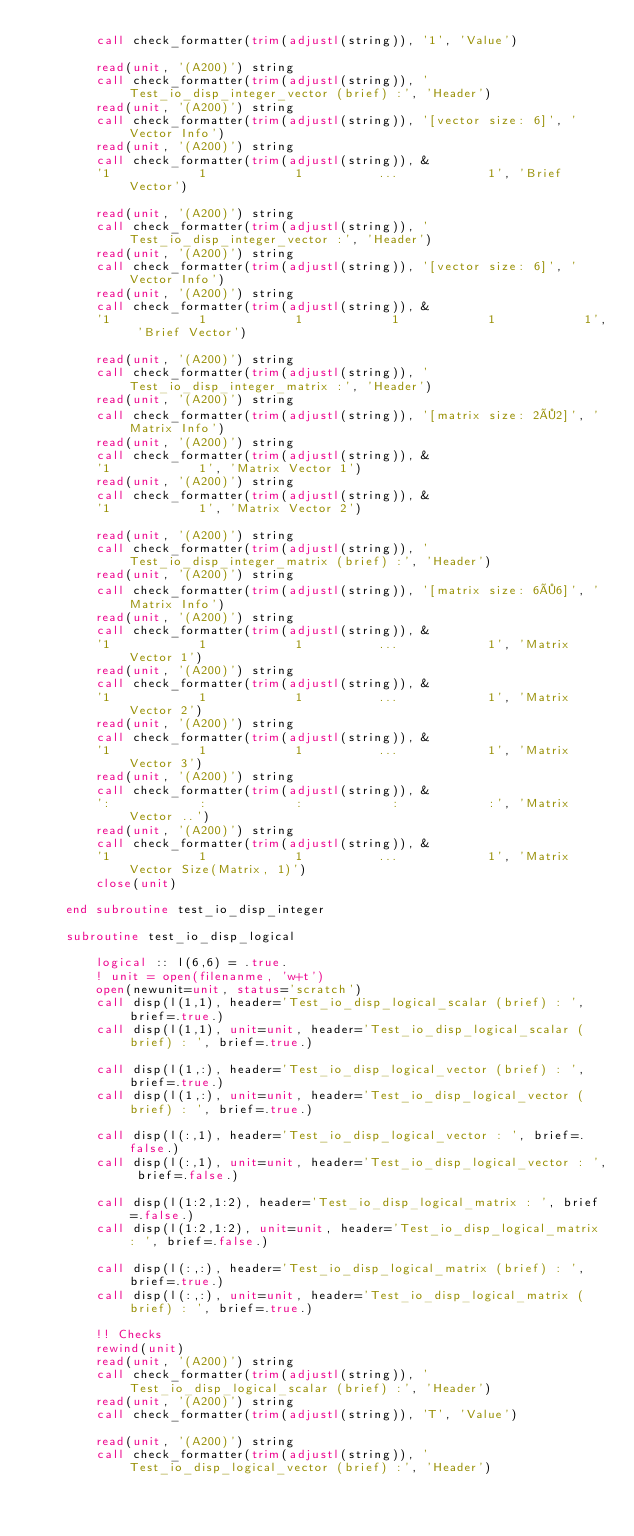<code> <loc_0><loc_0><loc_500><loc_500><_FORTRAN_>        call check_formatter(trim(adjustl(string)), '1', 'Value')

        read(unit, '(A200)') string
        call check_formatter(trim(adjustl(string)), 'Test_io_disp_integer_vector (brief) :', 'Header')
        read(unit, '(A200)') string
        call check_formatter(trim(adjustl(string)), '[vector size: 6]', 'Vector Info')
        read(unit, '(A200)') string
        call check_formatter(trim(adjustl(string)), &
        '1            1            1          ...            1', 'Brief Vector')

        read(unit, '(A200)') string
        call check_formatter(trim(adjustl(string)), 'Test_io_disp_integer_vector :', 'Header')
        read(unit, '(A200)') string
        call check_formatter(trim(adjustl(string)), '[vector size: 6]', 'Vector Info')
        read(unit, '(A200)') string
        call check_formatter(trim(adjustl(string)), &
        '1            1            1            1            1            1', 'Brief Vector')

        read(unit, '(A200)') string
        call check_formatter(trim(adjustl(string)), 'Test_io_disp_integer_matrix :', 'Header')
        read(unit, '(A200)') string
        call check_formatter(trim(adjustl(string)), '[matrix size: 2×2]', 'Matrix Info')
        read(unit, '(A200)') string
        call check_formatter(trim(adjustl(string)), &
        '1            1', 'Matrix Vector 1')
        read(unit, '(A200)') string
        call check_formatter(trim(adjustl(string)), &
        '1            1', 'Matrix Vector 2')

        read(unit, '(A200)') string
        call check_formatter(trim(adjustl(string)), 'Test_io_disp_integer_matrix (brief) :', 'Header')
        read(unit, '(A200)') string
        call check_formatter(trim(adjustl(string)), '[matrix size: 6×6]', 'Matrix Info')
        read(unit, '(A200)') string
        call check_formatter(trim(adjustl(string)), &
        '1            1            1          ...            1', 'Matrix Vector 1')
        read(unit, '(A200)') string
        call check_formatter(trim(adjustl(string)), &
        '1            1            1          ...            1', 'Matrix Vector 2')
        read(unit, '(A200)') string
        call check_formatter(trim(adjustl(string)), &
        '1            1            1          ...            1', 'Matrix Vector 3')
        read(unit, '(A200)') string
        call check_formatter(trim(adjustl(string)), &
        ':            :            :            :            :', 'Matrix Vector ..')
        read(unit, '(A200)') string
        call check_formatter(trim(adjustl(string)), &
        '1            1            1          ...            1', 'Matrix Vector Size(Matrix, 1)')
        close(unit)

    end subroutine test_io_disp_integer

    subroutine test_io_disp_logical

        logical :: l(6,6) = .true.
        ! unit = open(filenanme, 'w+t')
        open(newunit=unit, status='scratch')
        call disp(l(1,1), header='Test_io_disp_logical_scalar (brief) : ', brief=.true.)
        call disp(l(1,1), unit=unit, header='Test_io_disp_logical_scalar (brief) : ', brief=.true.)

        call disp(l(1,:), header='Test_io_disp_logical_vector (brief) : ', brief=.true.)
        call disp(l(1,:), unit=unit, header='Test_io_disp_logical_vector (brief) : ', brief=.true.)

        call disp(l(:,1), header='Test_io_disp_logical_vector : ', brief=.false.)
        call disp(l(:,1), unit=unit, header='Test_io_disp_logical_vector : ', brief=.false.)

        call disp(l(1:2,1:2), header='Test_io_disp_logical_matrix : ', brief=.false.)
        call disp(l(1:2,1:2), unit=unit, header='Test_io_disp_logical_matrix : ', brief=.false.)

        call disp(l(:,:), header='Test_io_disp_logical_matrix (brief) : ', brief=.true.)
        call disp(l(:,:), unit=unit, header='Test_io_disp_logical_matrix (brief) : ', brief=.true.)

        !! Checks
        rewind(unit)
        read(unit, '(A200)') string
        call check_formatter(trim(adjustl(string)), 'Test_io_disp_logical_scalar (brief) :', 'Header')
        read(unit, '(A200)') string
        call check_formatter(trim(adjustl(string)), 'T', 'Value')

        read(unit, '(A200)') string
        call check_formatter(trim(adjustl(string)), 'Test_io_disp_logical_vector (brief) :', 'Header')</code> 